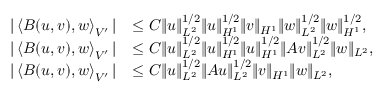Convert formula to latex. <formula><loc_0><loc_0><loc_500><loc_500>\begin{array} { r l } { | \left < B ( u , v ) , w \right > _ { V ^ { \prime } } | } & { \leq C \| u \| _ { L ^ { 2 } } ^ { 1 / 2 } \| u \| _ { H ^ { 1 } } ^ { 1 / 2 } \| v \| _ { H ^ { 1 } } \| w \| _ { L ^ { 2 } } ^ { 1 / 2 } \| w \| _ { H ^ { 1 } } ^ { 1 / 2 } , } \\ { | \left < B ( u , v ) , w \right > _ { V ^ { \prime } } | } & { \leq C \| u \| _ { L ^ { 2 } } ^ { 1 / 2 } \| u \| _ { H ^ { 1 } } ^ { 1 / 2 } \| u \| _ { H ^ { 1 } } ^ { 1 / 2 } \| A v \| _ { L ^ { 2 } } ^ { 1 / 2 } \| w \| _ { L ^ { 2 } } , } \\ { | \left < B ( u , v ) , w \right > _ { V ^ { \prime } } | } & { \leq C \| u \| _ { L ^ { 2 } } ^ { 1 / 2 } \| A u \| _ { L ^ { 2 } } ^ { 1 / 2 } \| v \| _ { H ^ { 1 } } \| w \| _ { L ^ { 2 } } , } \end{array}</formula> 